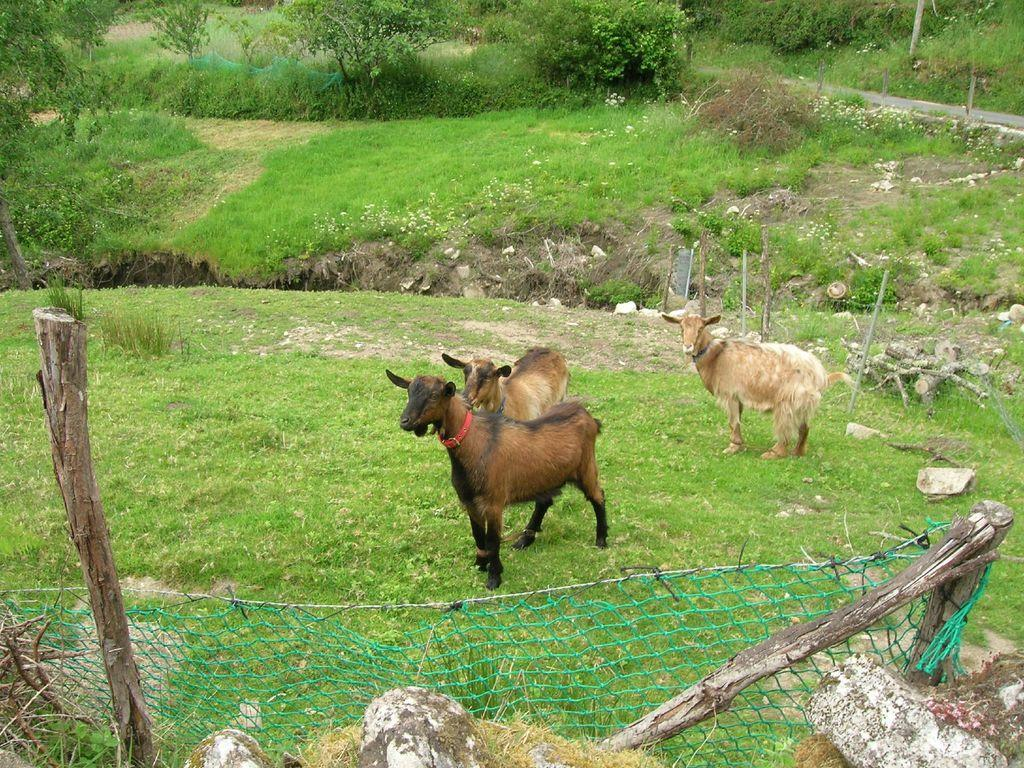What animals are present in the image? There are sheep standing on the ground in the image. What objects or structures can be seen in the background of the image? There are wooden sticks, a net, grass, plants, and rocks in the background of the image. How many sisters does the sheep in the image have? There is no information about the sheep's family in the image, so we cannot determine the number of sisters it has. What is the fifth object in the background of the image? The provided facts do not list the objects in the background in a specific order, so we cannot determine the fifth object. 